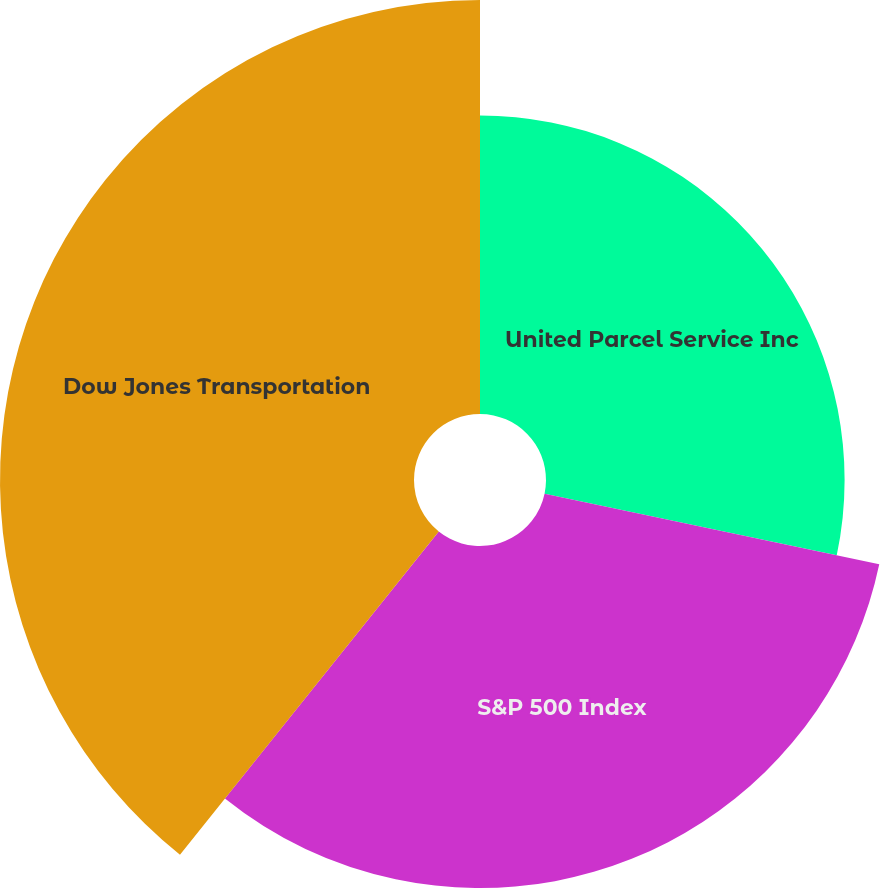<chart> <loc_0><loc_0><loc_500><loc_500><pie_chart><fcel>United Parcel Service Inc<fcel>S&P 500 Index<fcel>Dow Jones Transportation<nl><fcel>28.31%<fcel>32.43%<fcel>39.25%<nl></chart> 